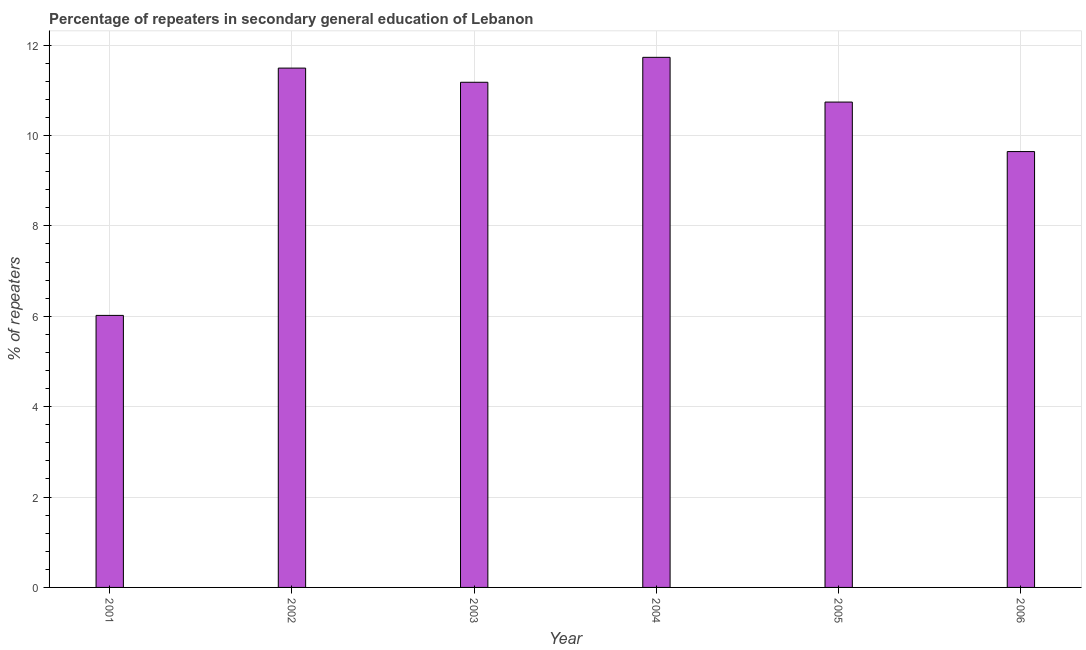Does the graph contain any zero values?
Provide a succinct answer. No. Does the graph contain grids?
Offer a very short reply. Yes. What is the title of the graph?
Offer a very short reply. Percentage of repeaters in secondary general education of Lebanon. What is the label or title of the X-axis?
Your response must be concise. Year. What is the label or title of the Y-axis?
Provide a succinct answer. % of repeaters. What is the percentage of repeaters in 2005?
Make the answer very short. 10.74. Across all years, what is the maximum percentage of repeaters?
Give a very brief answer. 11.73. Across all years, what is the minimum percentage of repeaters?
Provide a succinct answer. 6.02. What is the sum of the percentage of repeaters?
Offer a very short reply. 60.8. What is the difference between the percentage of repeaters in 2003 and 2004?
Your answer should be compact. -0.55. What is the average percentage of repeaters per year?
Keep it short and to the point. 10.13. What is the median percentage of repeaters?
Ensure brevity in your answer.  10.96. Do a majority of the years between 2001 and 2005 (inclusive) have percentage of repeaters greater than 10 %?
Offer a very short reply. Yes. What is the ratio of the percentage of repeaters in 2002 to that in 2005?
Make the answer very short. 1.07. What is the difference between the highest and the second highest percentage of repeaters?
Give a very brief answer. 0.24. Is the sum of the percentage of repeaters in 2005 and 2006 greater than the maximum percentage of repeaters across all years?
Your response must be concise. Yes. What is the difference between the highest and the lowest percentage of repeaters?
Ensure brevity in your answer.  5.71. In how many years, is the percentage of repeaters greater than the average percentage of repeaters taken over all years?
Your answer should be very brief. 4. What is the % of repeaters in 2001?
Your response must be concise. 6.02. What is the % of repeaters of 2002?
Offer a terse response. 11.49. What is the % of repeaters of 2003?
Make the answer very short. 11.18. What is the % of repeaters of 2004?
Your response must be concise. 11.73. What is the % of repeaters in 2005?
Provide a succinct answer. 10.74. What is the % of repeaters in 2006?
Make the answer very short. 9.64. What is the difference between the % of repeaters in 2001 and 2002?
Offer a very short reply. -5.47. What is the difference between the % of repeaters in 2001 and 2003?
Offer a terse response. -5.16. What is the difference between the % of repeaters in 2001 and 2004?
Ensure brevity in your answer.  -5.71. What is the difference between the % of repeaters in 2001 and 2005?
Offer a terse response. -4.72. What is the difference between the % of repeaters in 2001 and 2006?
Keep it short and to the point. -3.62. What is the difference between the % of repeaters in 2002 and 2003?
Provide a short and direct response. 0.31. What is the difference between the % of repeaters in 2002 and 2004?
Provide a succinct answer. -0.24. What is the difference between the % of repeaters in 2002 and 2005?
Your answer should be very brief. 0.75. What is the difference between the % of repeaters in 2002 and 2006?
Provide a short and direct response. 1.85. What is the difference between the % of repeaters in 2003 and 2004?
Make the answer very short. -0.55. What is the difference between the % of repeaters in 2003 and 2005?
Your response must be concise. 0.44. What is the difference between the % of repeaters in 2003 and 2006?
Offer a very short reply. 1.53. What is the difference between the % of repeaters in 2004 and 2005?
Ensure brevity in your answer.  0.99. What is the difference between the % of repeaters in 2004 and 2006?
Provide a succinct answer. 2.09. What is the difference between the % of repeaters in 2005 and 2006?
Offer a very short reply. 1.1. What is the ratio of the % of repeaters in 2001 to that in 2002?
Make the answer very short. 0.52. What is the ratio of the % of repeaters in 2001 to that in 2003?
Keep it short and to the point. 0.54. What is the ratio of the % of repeaters in 2001 to that in 2004?
Make the answer very short. 0.51. What is the ratio of the % of repeaters in 2001 to that in 2005?
Give a very brief answer. 0.56. What is the ratio of the % of repeaters in 2001 to that in 2006?
Keep it short and to the point. 0.62. What is the ratio of the % of repeaters in 2002 to that in 2003?
Provide a succinct answer. 1.03. What is the ratio of the % of repeaters in 2002 to that in 2005?
Keep it short and to the point. 1.07. What is the ratio of the % of repeaters in 2002 to that in 2006?
Ensure brevity in your answer.  1.19. What is the ratio of the % of repeaters in 2003 to that in 2004?
Your answer should be very brief. 0.95. What is the ratio of the % of repeaters in 2003 to that in 2005?
Offer a terse response. 1.04. What is the ratio of the % of repeaters in 2003 to that in 2006?
Offer a very short reply. 1.16. What is the ratio of the % of repeaters in 2004 to that in 2005?
Make the answer very short. 1.09. What is the ratio of the % of repeaters in 2004 to that in 2006?
Your response must be concise. 1.22. What is the ratio of the % of repeaters in 2005 to that in 2006?
Offer a terse response. 1.11. 